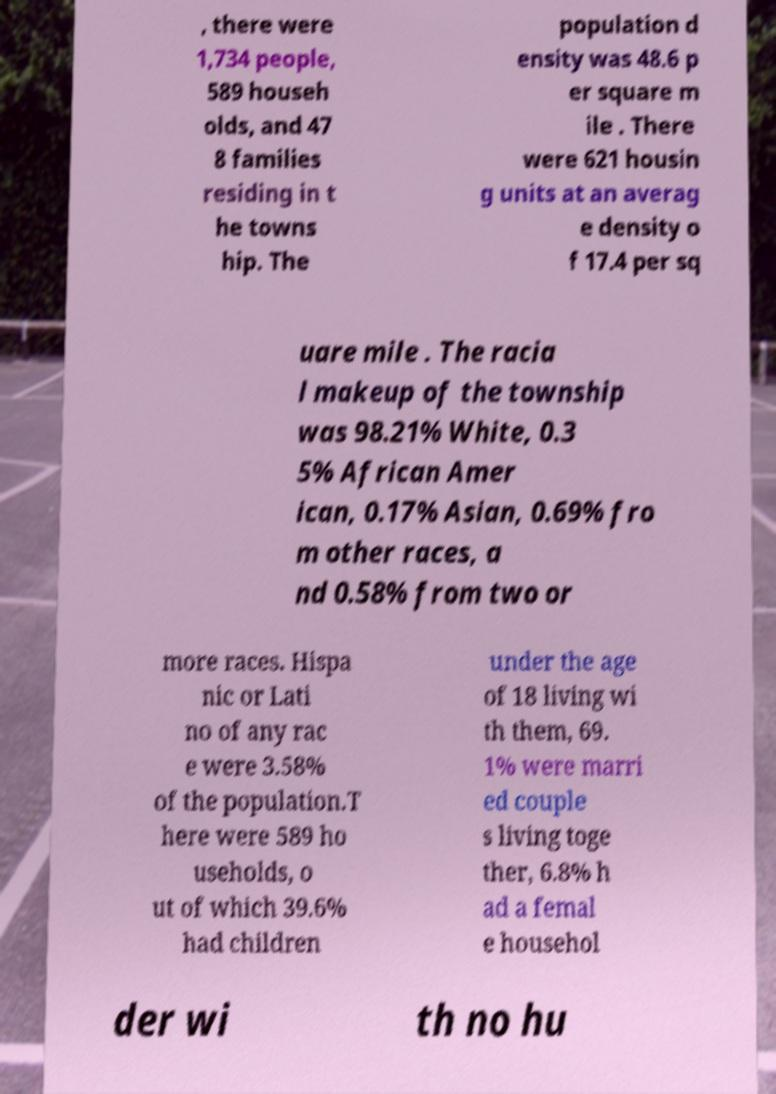Could you extract and type out the text from this image? , there were 1,734 people, 589 househ olds, and 47 8 families residing in t he towns hip. The population d ensity was 48.6 p er square m ile . There were 621 housin g units at an averag e density o f 17.4 per sq uare mile . The racia l makeup of the township was 98.21% White, 0.3 5% African Amer ican, 0.17% Asian, 0.69% fro m other races, a nd 0.58% from two or more races. Hispa nic or Lati no of any rac e were 3.58% of the population.T here were 589 ho useholds, o ut of which 39.6% had children under the age of 18 living wi th them, 69. 1% were marri ed couple s living toge ther, 6.8% h ad a femal e househol der wi th no hu 